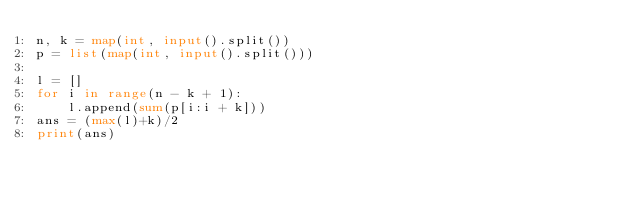<code> <loc_0><loc_0><loc_500><loc_500><_Python_>n, k = map(int, input().split())
p = list(map(int, input().split()))

l = []
for i in range(n - k + 1):
    l.append(sum(p[i:i + k]))
ans = (max(l)+k)/2
print(ans)
</code> 